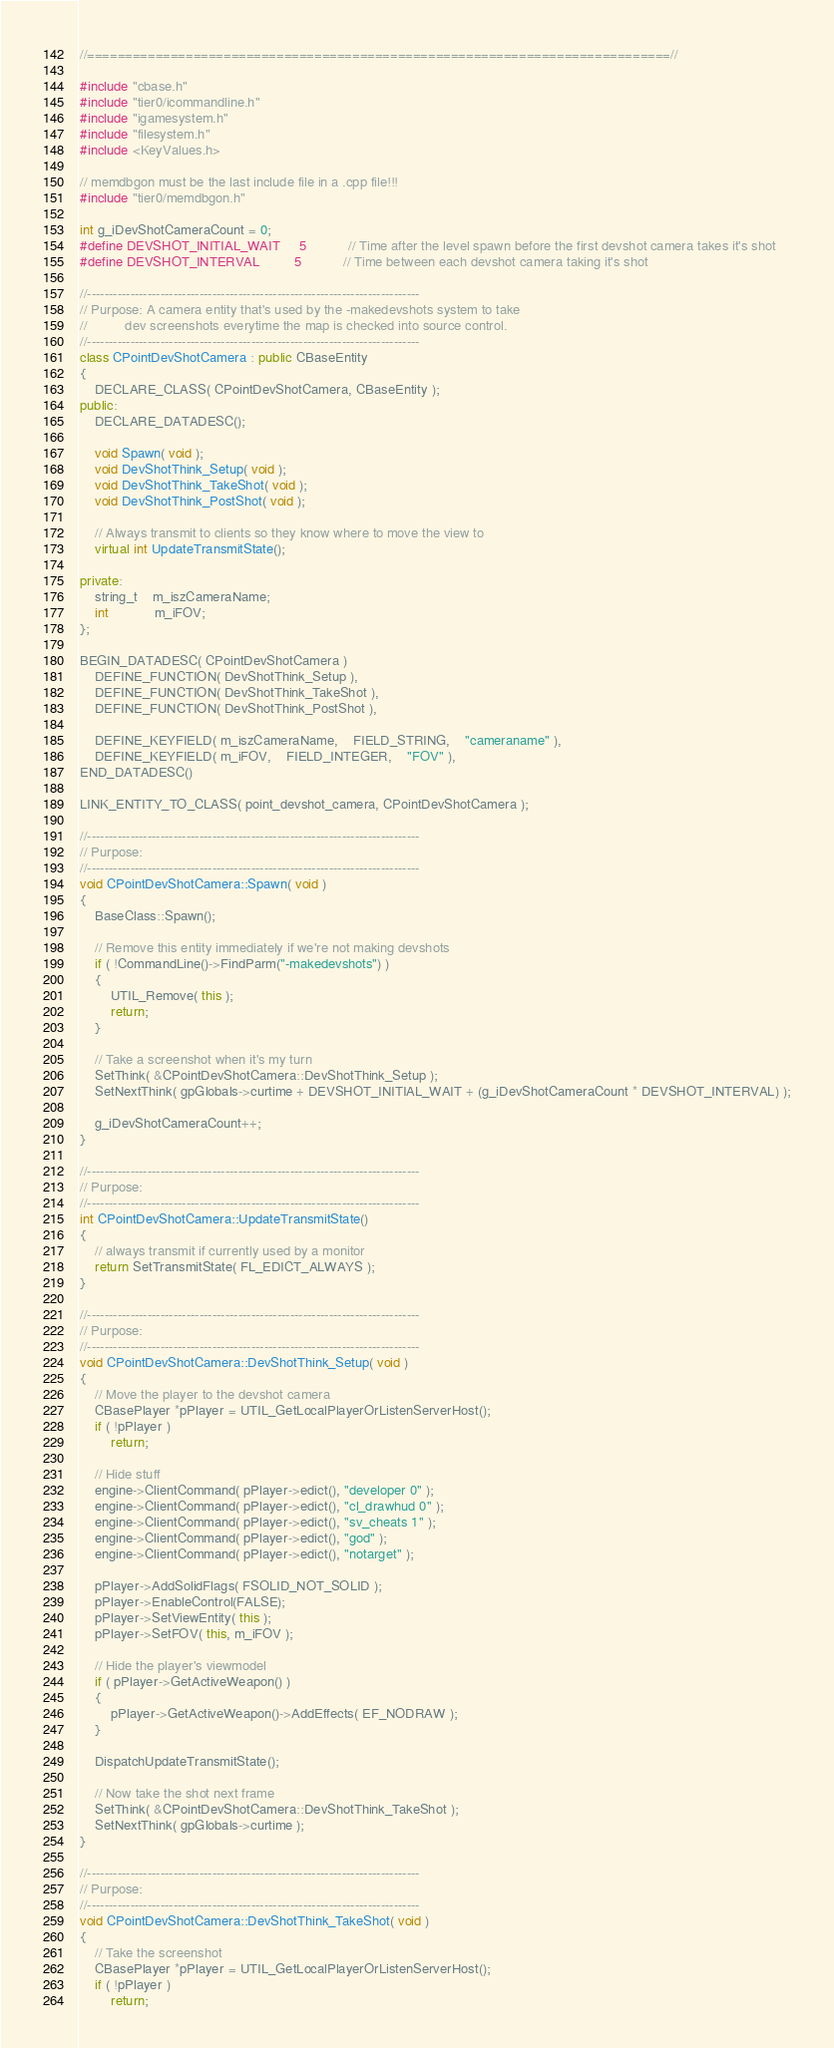<code> <loc_0><loc_0><loc_500><loc_500><_C++_>//=============================================================================//

#include "cbase.h"
#include "tier0/icommandline.h"
#include "igamesystem.h"
#include "filesystem.h"
#include <KeyValues.h>

// memdbgon must be the last include file in a .cpp file!!!
#include "tier0/memdbgon.h"

int g_iDevShotCameraCount = 0;
#define DEVSHOT_INITIAL_WAIT		5			// Time after the level spawn before the first devshot camera takes it's shot
#define DEVSHOT_INTERVAL			5			// Time between each devshot camera taking it's shot

//-----------------------------------------------------------------------------
// Purpose: A camera entity that's used by the -makedevshots system to take
//			dev screenshots everytime the map is checked into source control.
//-----------------------------------------------------------------------------
class CPointDevShotCamera : public CBaseEntity
{
	DECLARE_CLASS( CPointDevShotCamera, CBaseEntity );
public:
	DECLARE_DATADESC();

	void Spawn( void );
	void DevShotThink_Setup( void );
	void DevShotThink_TakeShot( void );
	void DevShotThink_PostShot( void );

	// Always transmit to clients so they know where to move the view to
	virtual int UpdateTransmitState();

private:
	string_t	m_iszCameraName;
	int			m_iFOV;
};

BEGIN_DATADESC( CPointDevShotCamera )
	DEFINE_FUNCTION( DevShotThink_Setup ),
	DEFINE_FUNCTION( DevShotThink_TakeShot ),
	DEFINE_FUNCTION( DevShotThink_PostShot ),

	DEFINE_KEYFIELD( m_iszCameraName,	FIELD_STRING,	"cameraname" ),
	DEFINE_KEYFIELD( m_iFOV,	FIELD_INTEGER,	"FOV" ),
END_DATADESC()

LINK_ENTITY_TO_CLASS( point_devshot_camera, CPointDevShotCamera );

//-----------------------------------------------------------------------------
// Purpose: 
//-----------------------------------------------------------------------------
void CPointDevShotCamera::Spawn( void )
{
	BaseClass::Spawn();

	// Remove this entity immediately if we're not making devshots
	if ( !CommandLine()->FindParm("-makedevshots") )
	{
		UTIL_Remove( this );
		return;
	}

	// Take a screenshot when it's my turn
	SetThink( &CPointDevShotCamera::DevShotThink_Setup );
	SetNextThink( gpGlobals->curtime + DEVSHOT_INITIAL_WAIT + (g_iDevShotCameraCount * DEVSHOT_INTERVAL) );

	g_iDevShotCameraCount++;
}

//-----------------------------------------------------------------------------
// Purpose: 
//-----------------------------------------------------------------------------
int CPointDevShotCamera::UpdateTransmitState()
{
	// always transmit if currently used by a monitor
	return SetTransmitState( FL_EDICT_ALWAYS );
}

//-----------------------------------------------------------------------------
// Purpose: 
//-----------------------------------------------------------------------------
void CPointDevShotCamera::DevShotThink_Setup( void )
{
	// Move the player to the devshot camera
	CBasePlayer *pPlayer = UTIL_GetLocalPlayerOrListenServerHost();
	if ( !pPlayer )
		return;

	// Hide stuff
	engine->ClientCommand( pPlayer->edict(), "developer 0" );
	engine->ClientCommand( pPlayer->edict(), "cl_drawhud 0" );
	engine->ClientCommand( pPlayer->edict(), "sv_cheats 1" );
	engine->ClientCommand( pPlayer->edict(), "god" );
	engine->ClientCommand( pPlayer->edict(), "notarget" );

	pPlayer->AddSolidFlags( FSOLID_NOT_SOLID );
	pPlayer->EnableControl(FALSE);
	pPlayer->SetViewEntity( this );
	pPlayer->SetFOV( this, m_iFOV );

	// Hide the player's viewmodel
	if ( pPlayer->GetActiveWeapon() )
	{
		pPlayer->GetActiveWeapon()->AddEffects( EF_NODRAW );
	}

	DispatchUpdateTransmitState();

	// Now take the shot next frame
	SetThink( &CPointDevShotCamera::DevShotThink_TakeShot );
	SetNextThink( gpGlobals->curtime );
}

//-----------------------------------------------------------------------------
// Purpose: 
//-----------------------------------------------------------------------------
void CPointDevShotCamera::DevShotThink_TakeShot( void )
{
	// Take the screenshot
	CBasePlayer *pPlayer = UTIL_GetLocalPlayerOrListenServerHost();
	if ( !pPlayer )
		return;
</code> 